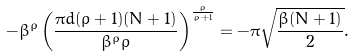Convert formula to latex. <formula><loc_0><loc_0><loc_500><loc_500>- \beta ^ { \rho } \left ( \frac { \pi d ( \rho + 1 ) ( N + 1 ) } { \beta ^ { \rho } \rho } \right ) ^ { \frac { \rho } { \rho + 1 } } = - \pi \sqrt { \frac { \beta ( N + 1 ) } { 2 } } .</formula> 